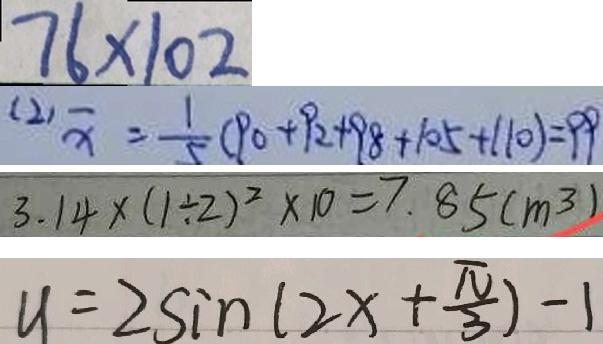<formula> <loc_0><loc_0><loc_500><loc_500>7 6 \times 1 0 2 
 ( 2 ) \overline { x } = \frac { 1 } { 5 } ( 9 0 + 9 2 + 9 8 + 1 0 5 + 1 1 0 ) = 9 9 
 3 . 1 4 \times ( 1 \div 2 ) ^ { 2 } \times 1 0 = 7 . 8 5 ( m ^ { 3 } ) 
 y = 2 \sin ( 2 x + \frac { \pi } { 3 } ) - 1</formula> 